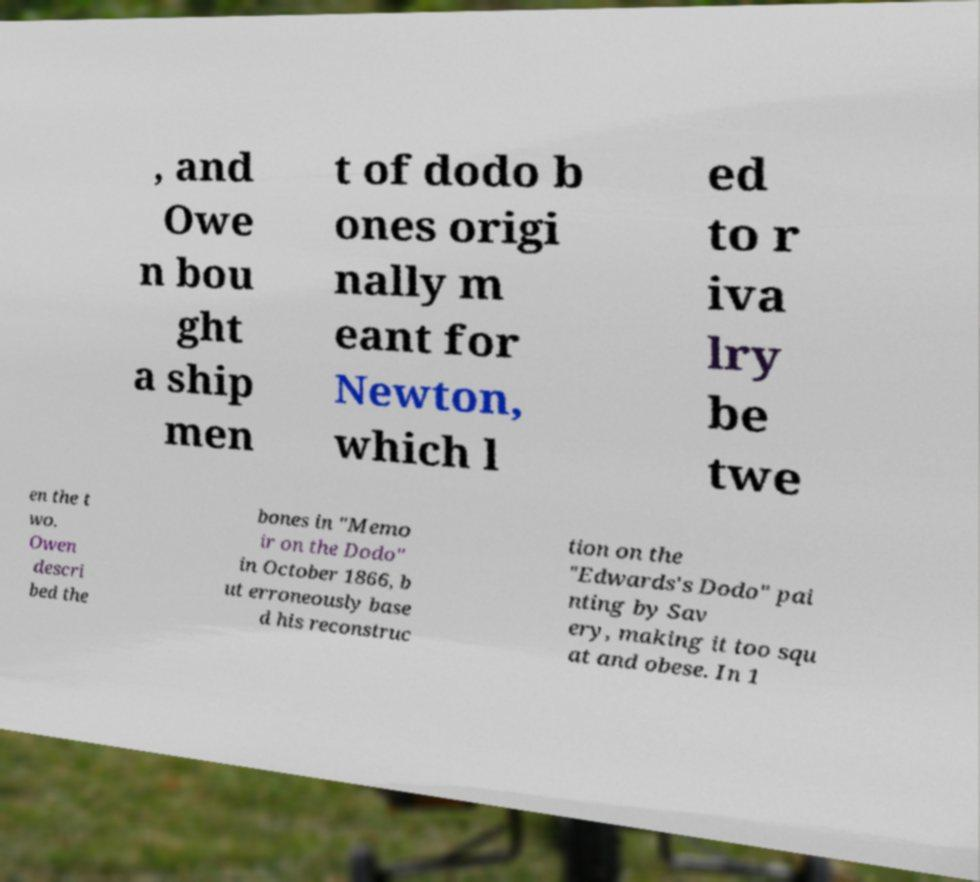Can you accurately transcribe the text from the provided image for me? , and Owe n bou ght a ship men t of dodo b ones origi nally m eant for Newton, which l ed to r iva lry be twe en the t wo. Owen descri bed the bones in "Memo ir on the Dodo" in October 1866, b ut erroneously base d his reconstruc tion on the "Edwards's Dodo" pai nting by Sav ery, making it too squ at and obese. In 1 